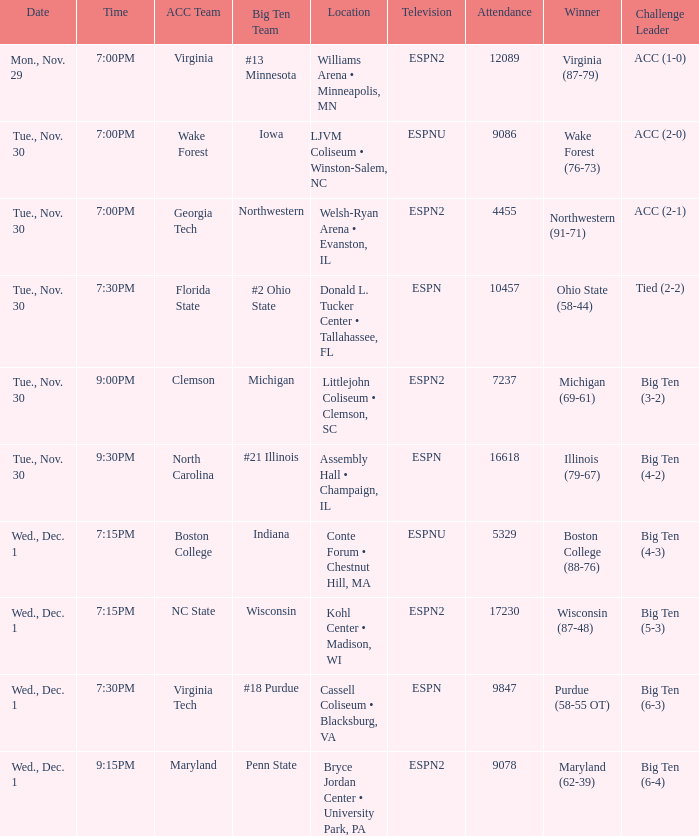Where did the games that had Wisconsin as big ten team take place? Kohl Center • Madison, WI. 